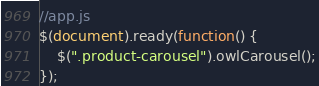<code> <loc_0><loc_0><loc_500><loc_500><_JavaScript_>//app.js
$(document).ready(function() {
	$(".product-carousel").owlCarousel();
});</code> 